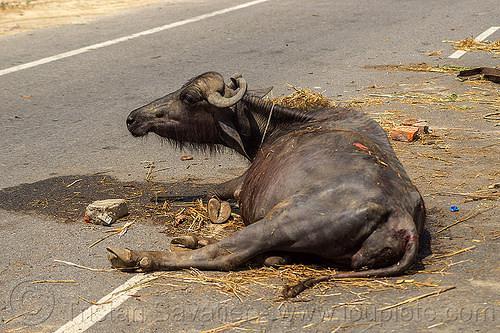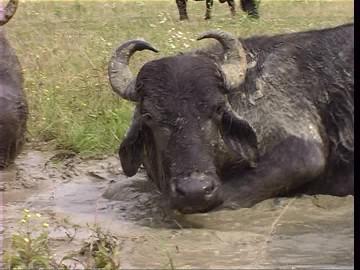The first image is the image on the left, the second image is the image on the right. Examine the images to the left and right. Is the description "All water buffalo are standing, and one image contains multiple water buffalo." accurate? Answer yes or no. No. The first image is the image on the left, the second image is the image on the right. For the images shown, is this caption "The cow in the image on the left is lying down." true? Answer yes or no. Yes. 